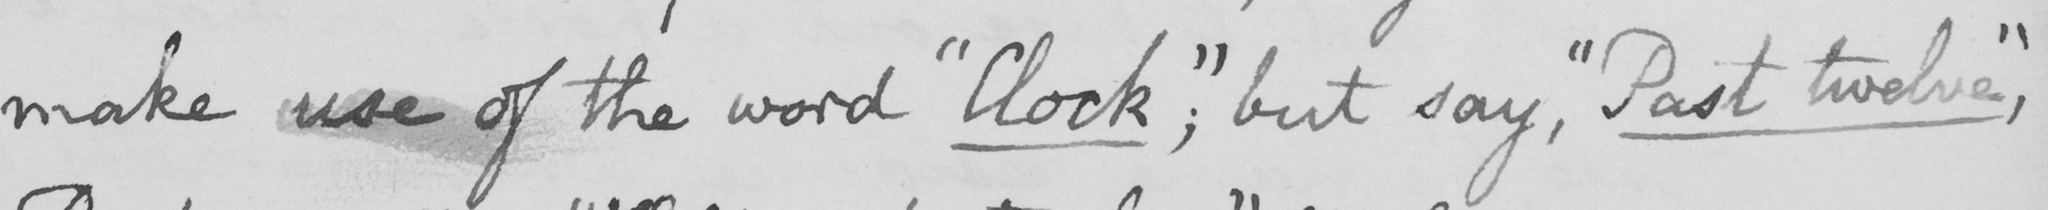What does this handwritten line say? make use of the word  " Clock; "  but say ,  " Past twelve , " 